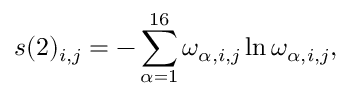<formula> <loc_0><loc_0><loc_500><loc_500>s ( 2 ) _ { i , j } = - \sum _ { \alpha = 1 } ^ { 1 6 } \omega _ { \alpha , i , j } \ln \omega _ { \alpha , i , j } ,</formula> 